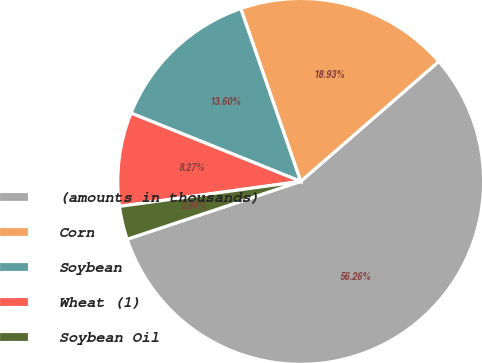Convert chart. <chart><loc_0><loc_0><loc_500><loc_500><pie_chart><fcel>(amounts in thousands)<fcel>Corn<fcel>Soybean<fcel>Wheat (1)<fcel>Soybean Oil<nl><fcel>56.26%<fcel>18.93%<fcel>13.6%<fcel>8.27%<fcel>2.94%<nl></chart> 